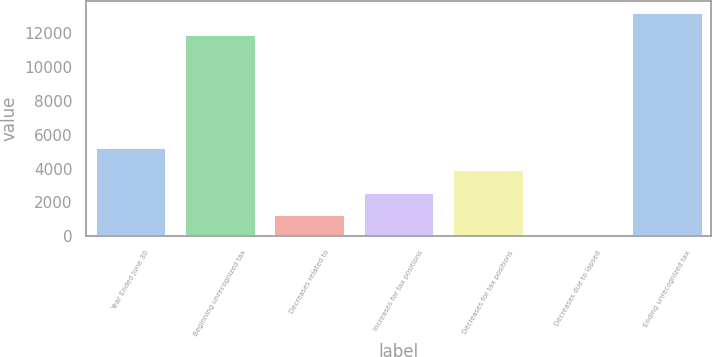Convert chart to OTSL. <chart><loc_0><loc_0><loc_500><loc_500><bar_chart><fcel>Year Ended June 30<fcel>Beginning unrecognized tax<fcel>Decreases related to<fcel>Increases for tax positions<fcel>Decreases for tax positions<fcel>Decreases due to lapsed<fcel>Ending unrecognized tax<nl><fcel>5261.12<fcel>11961<fcel>1318.67<fcel>2632.82<fcel>3946.97<fcel>4.52<fcel>13275.1<nl></chart> 